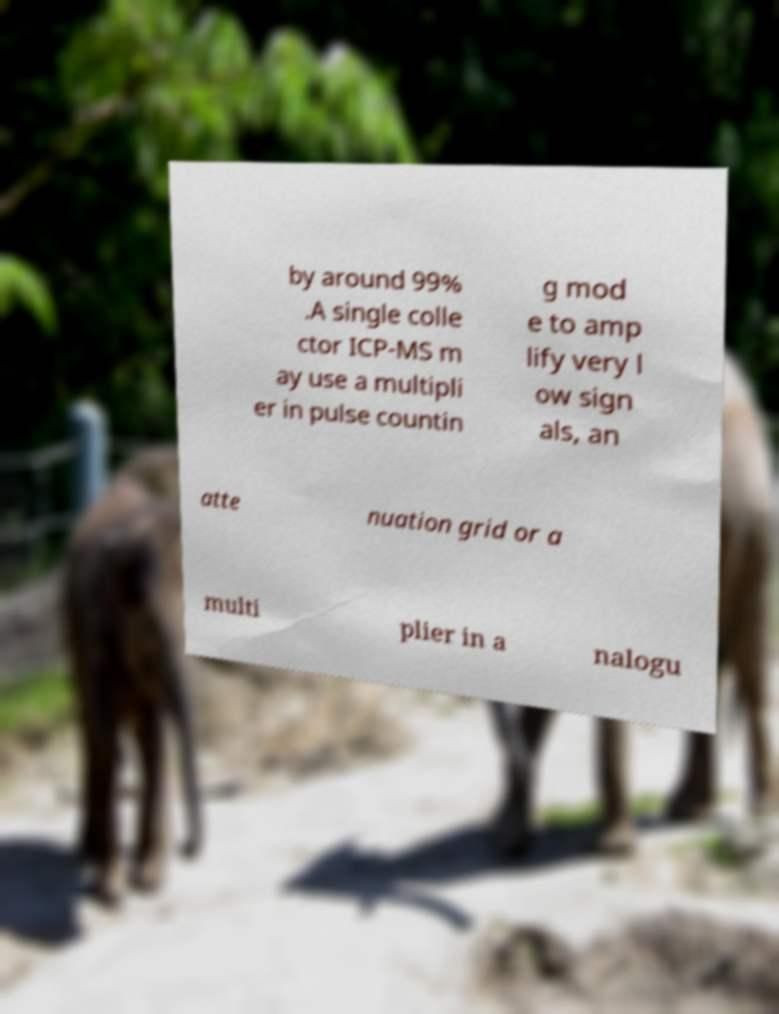What messages or text are displayed in this image? I need them in a readable, typed format. by around 99% .A single colle ctor ICP-MS m ay use a multipli er in pulse countin g mod e to amp lify very l ow sign als, an atte nuation grid or a multi plier in a nalogu 